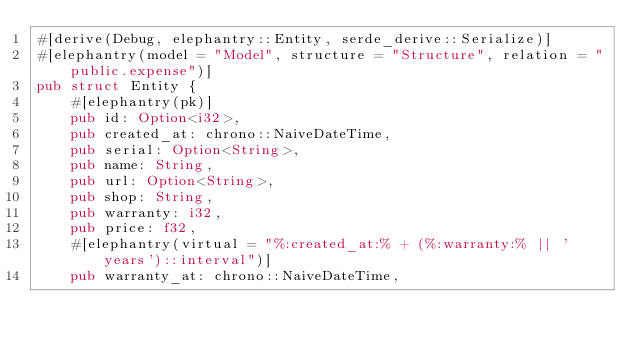Convert code to text. <code><loc_0><loc_0><loc_500><loc_500><_Rust_>#[derive(Debug, elephantry::Entity, serde_derive::Serialize)]
#[elephantry(model = "Model", structure = "Structure", relation = "public.expense")]
pub struct Entity {
    #[elephantry(pk)]
    pub id: Option<i32>,
    pub created_at: chrono::NaiveDateTime,
    pub serial: Option<String>,
    pub name: String,
    pub url: Option<String>,
    pub shop: String,
    pub warranty: i32,
    pub price: f32,
    #[elephantry(virtual = "%:created_at:% + (%:warranty:% || ' years')::interval")]
    pub warranty_at: chrono::NaiveDateTime,</code> 